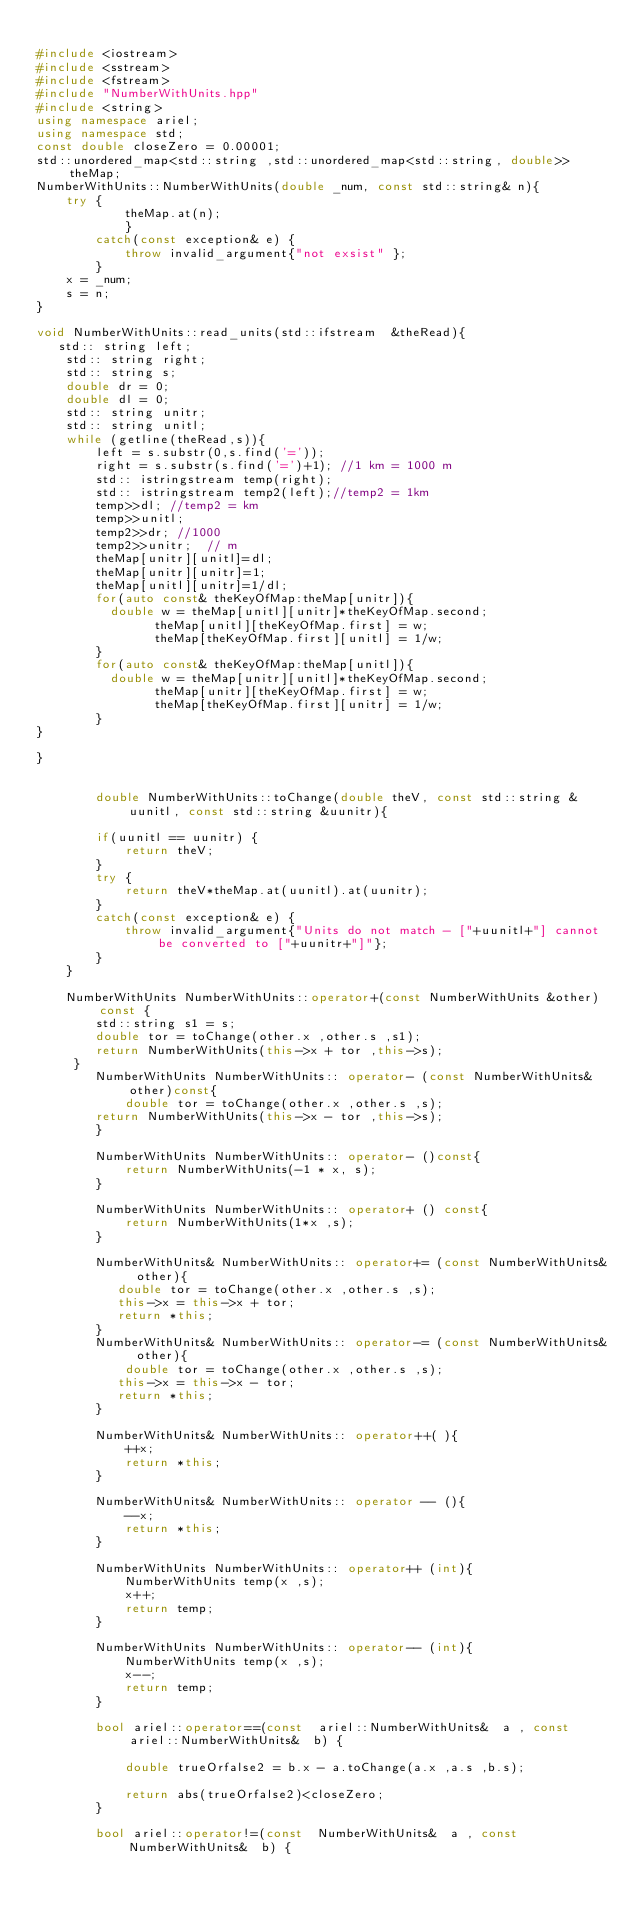Convert code to text. <code><loc_0><loc_0><loc_500><loc_500><_C++_>
#include <iostream>
#include <sstream>
#include <fstream>
#include "NumberWithUnits.hpp"
#include <string>
using namespace ariel;
using namespace std;
const double closeZero = 0.00001;
std::unordered_map<std::string ,std::unordered_map<std::string, double>> theMap;
NumberWithUnits::NumberWithUnits(double _num, const std::string& n){
    try {
            theMap.at(n);
            }
        catch(const exception& e) {
            throw invalid_argument{"not exsist" };
        }
    x = _num;
    s = n;
}

void NumberWithUnits::read_units(std::ifstream  &theRead){
   std:: string left;
    std:: string right;
    std:: string s;
    double dr = 0;
    double dl = 0;
    std:: string unitr;
    std:: string unitl;
    while (getline(theRead,s)){
        left = s.substr(0,s.find('='));
        right = s.substr(s.find('=')+1); //1 km = 1000 m
        std:: istringstream temp(right);
        std:: istringstream temp2(left);//temp2 = 1km   
        temp>>dl; //temp2 = km
        temp>>unitl;
        temp2>>dr; //1000
        temp2>>unitr;  // m
        theMap[unitr][unitl]=dl;
        theMap[unitr][unitr]=1; 
        theMap[unitl][unitr]=1/dl;
        for(auto const& theKeyOfMap:theMap[unitr]){
          double w = theMap[unitl][unitr]*theKeyOfMap.second;
                theMap[unitl][theKeyOfMap.first] = w;
                theMap[theKeyOfMap.first][unitl] = 1/w;
        }
        for(auto const& theKeyOfMap:theMap[unitl]){
          double w = theMap[unitr][unitl]*theKeyOfMap.second;
                theMap[unitr][theKeyOfMap.first] = w;
                theMap[theKeyOfMap.first][unitr] = 1/w;
        }
}
        
}


        double NumberWithUnits::toChange(double theV, const std::string &uunitl, const std::string &uunitr){
         
        if(uunitl == uunitr) {
            return theV;
        }
        try {
            return theV*theMap.at(uunitl).at(uunitr);
        }
        catch(const exception& e) {
            throw invalid_argument{"Units do not match - ["+uunitl+"] cannot be converted to ["+uunitr+"]"};
        }
    }

    NumberWithUnits NumberWithUnits::operator+(const NumberWithUnits &other)const {
        std::string s1 = s;
        double tor = toChange(other.x ,other.s ,s1);
        return NumberWithUnits(this->x + tor ,this->s);
     }
        NumberWithUnits NumberWithUnits:: operator- (const NumberWithUnits& other)const{
            double tor = toChange(other.x ,other.s ,s);
        return NumberWithUnits(this->x - tor ,this->s);
        }

        NumberWithUnits NumberWithUnits:: operator- ()const{
            return NumberWithUnits(-1 * x, s);
        }

        NumberWithUnits NumberWithUnits:: operator+ () const{
            return NumberWithUnits(1*x ,s);
        }

        NumberWithUnits& NumberWithUnits:: operator+= (const NumberWithUnits& other){
           double tor = toChange(other.x ,other.s ,s);
           this->x = this->x + tor;
           return *this;
        }
        NumberWithUnits& NumberWithUnits:: operator-= (const NumberWithUnits& other){
            double tor = toChange(other.x ,other.s ,s);
           this->x = this->x - tor;
           return *this;
        }

        NumberWithUnits& NumberWithUnits:: operator++( ){
            ++x;
            return *this;
        }

        NumberWithUnits& NumberWithUnits:: operator -- (){
            --x;
            return *this;
        }

        NumberWithUnits NumberWithUnits:: operator++ (int){
            NumberWithUnits temp(x ,s);
            x++;
            return temp;
        }
        
        NumberWithUnits NumberWithUnits:: operator-- (int){
            NumberWithUnits temp(x ,s);
            x--;
            return temp;
        }
        
        bool ariel::operator==(const  ariel::NumberWithUnits&  a , const  ariel::NumberWithUnits&  b) {
         
            double trueOrfalse2 = b.x - a.toChange(a.x ,a.s ,b.s);
           
            return abs(trueOrfalse2)<closeZero;
        }

        bool ariel::operator!=(const  NumberWithUnits&  a , const  NumberWithUnits&  b) {</code> 